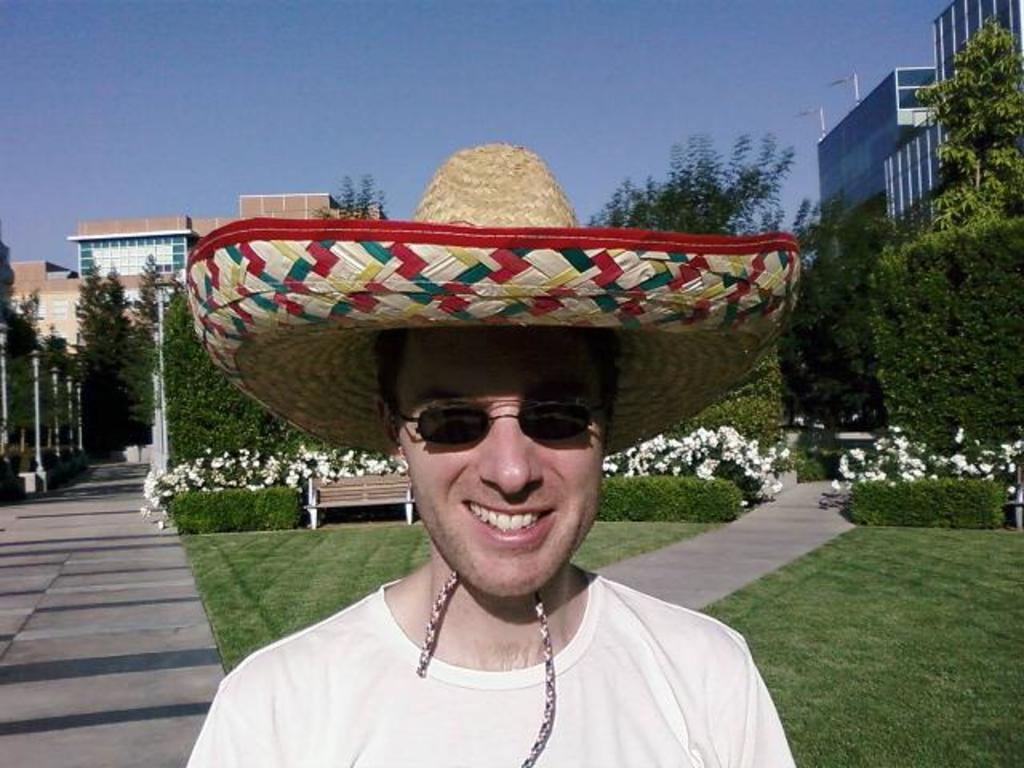Who is present in the image? There is a man in the image. What is the man's facial expression? The man is smiling. What accessories is the man wearing? The man is wearing spectacles and a cap. What can be seen in the background of the image? There is a bench, flowers, trees, poles, and buildings in the background of the image. What type of pen is the man holding in the image? There is no pen present in the image; the man is not holding any object. 